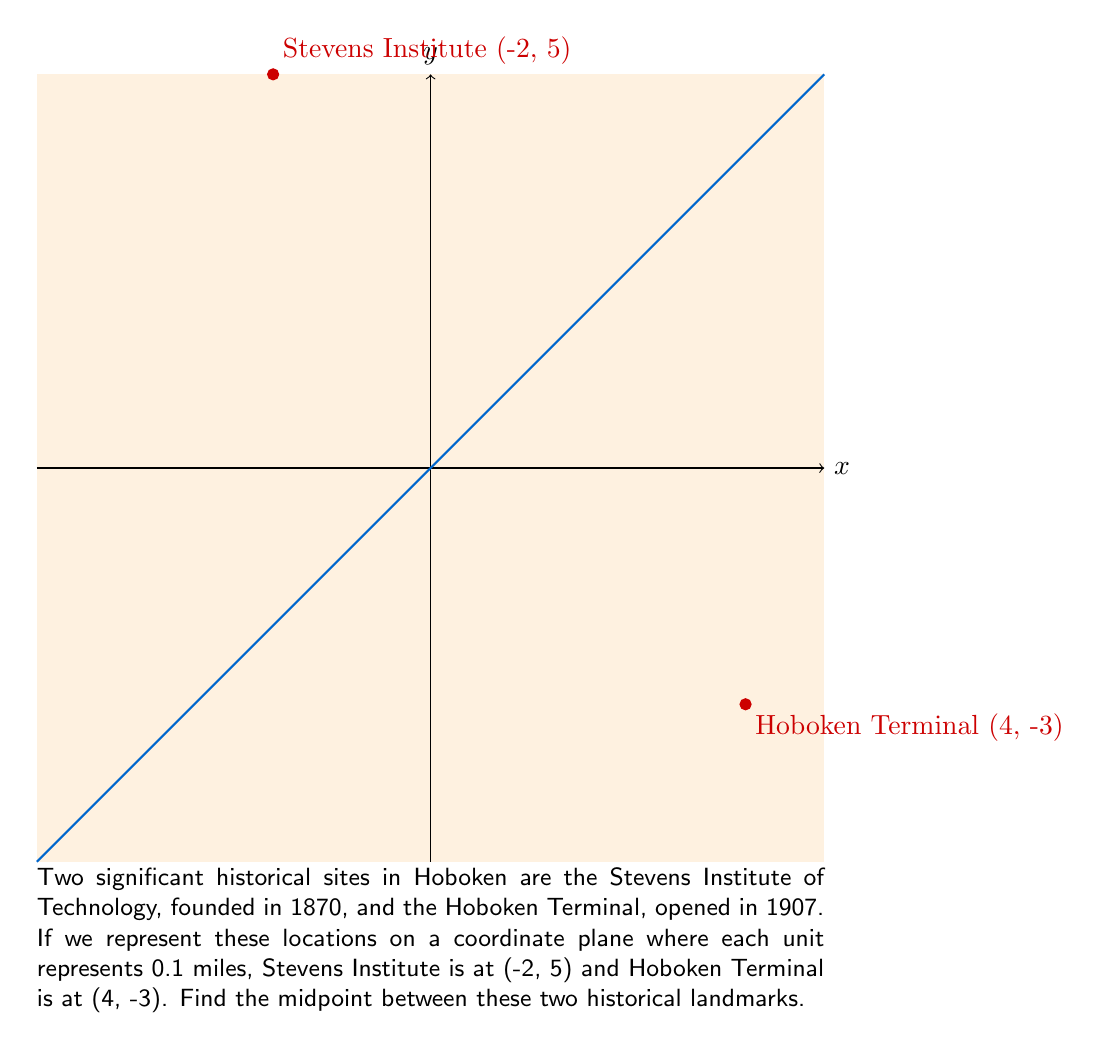Give your solution to this math problem. To find the midpoint between two points, we use the midpoint formula:

$$ \text{Midpoint} = \left(\frac{x_1 + x_2}{2}, \frac{y_1 + y_2}{2}\right) $$

Where $(x_1, y_1)$ is the coordinate of the first point and $(x_2, y_2)$ is the coordinate of the second point.

For our problem:
$(x_1, y_1) = (-2, 5)$ (Stevens Institute)
$(x_2, y_2) = (4, -3)$ (Hoboken Terminal)

Let's calculate the x-coordinate of the midpoint:
$$ x = \frac{x_1 + x_2}{2} = \frac{-2 + 4}{2} = \frac{2}{2} = 1 $$

Now, let's calculate the y-coordinate of the midpoint:
$$ y = \frac{y_1 + y_2}{2} = \frac{5 + (-3)}{2} = \frac{2}{2} = 1 $$

Therefore, the midpoint is (1, 1).

Since each unit represents 0.1 miles, this midpoint is located 0.1 miles east and 0.1 miles north of the origin on our coordinate system.
Answer: (1, 1) 